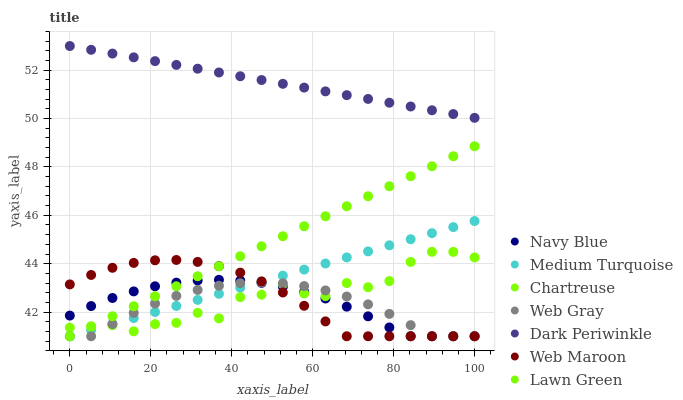Does Web Gray have the minimum area under the curve?
Answer yes or no. Yes. Does Dark Periwinkle have the maximum area under the curve?
Answer yes or no. Yes. Does Navy Blue have the minimum area under the curve?
Answer yes or no. No. Does Navy Blue have the maximum area under the curve?
Answer yes or no. No. Is Lawn Green the smoothest?
Answer yes or no. Yes. Is Chartreuse the roughest?
Answer yes or no. Yes. Is Web Gray the smoothest?
Answer yes or no. No. Is Web Gray the roughest?
Answer yes or no. No. Does Lawn Green have the lowest value?
Answer yes or no. Yes. Does Chartreuse have the lowest value?
Answer yes or no. No. Does Dark Periwinkle have the highest value?
Answer yes or no. Yes. Does Navy Blue have the highest value?
Answer yes or no. No. Is Chartreuse less than Dark Periwinkle?
Answer yes or no. Yes. Is Dark Periwinkle greater than Chartreuse?
Answer yes or no. Yes. Does Chartreuse intersect Medium Turquoise?
Answer yes or no. Yes. Is Chartreuse less than Medium Turquoise?
Answer yes or no. No. Is Chartreuse greater than Medium Turquoise?
Answer yes or no. No. Does Chartreuse intersect Dark Periwinkle?
Answer yes or no. No. 